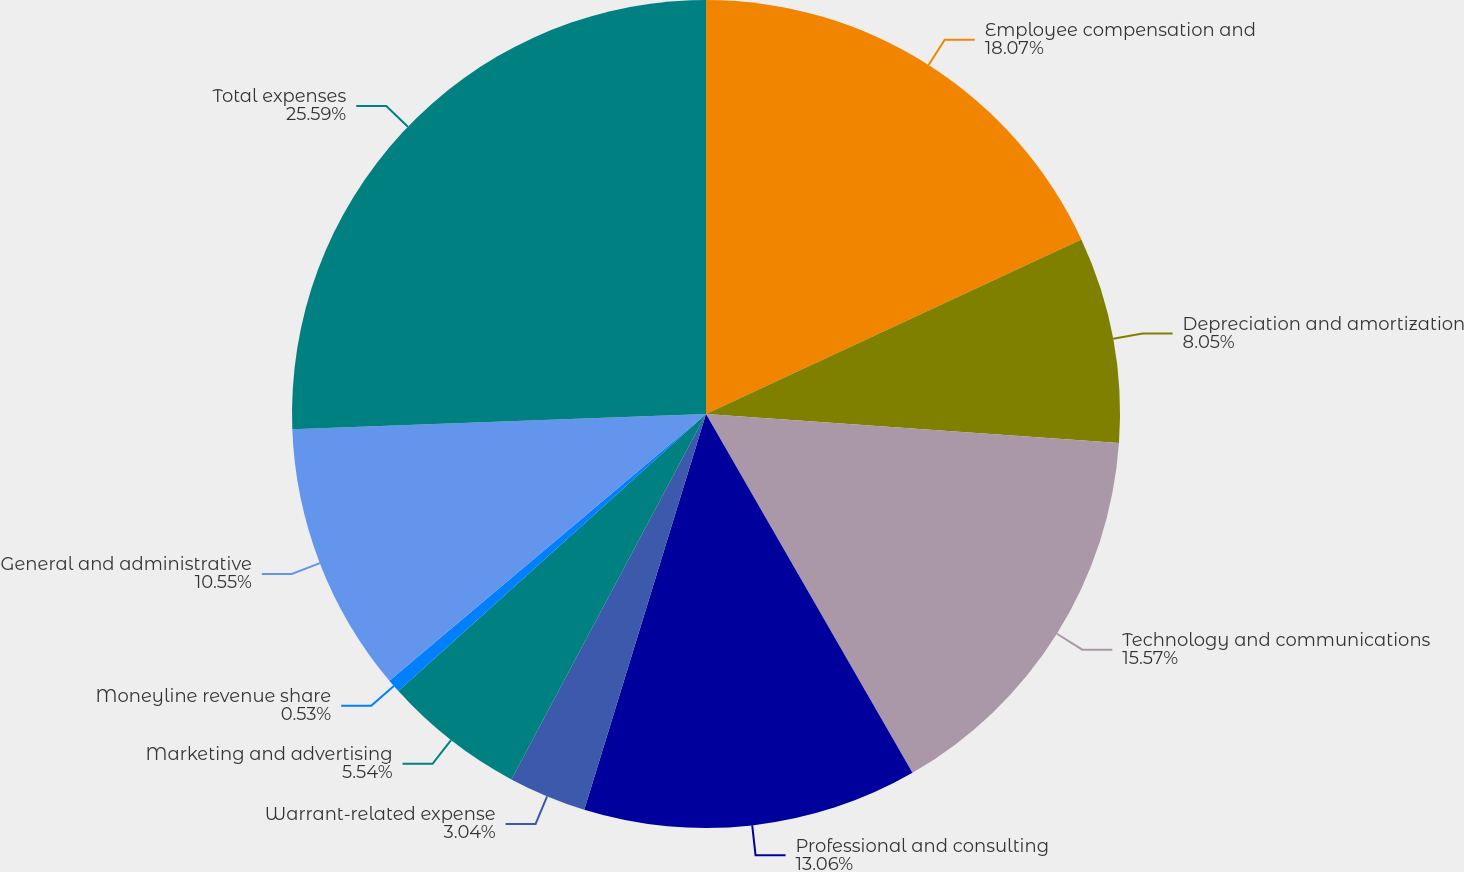Convert chart to OTSL. <chart><loc_0><loc_0><loc_500><loc_500><pie_chart><fcel>Employee compensation and<fcel>Depreciation and amortization<fcel>Technology and communications<fcel>Professional and consulting<fcel>Warrant-related expense<fcel>Marketing and advertising<fcel>Moneyline revenue share<fcel>General and administrative<fcel>Total expenses<nl><fcel>18.07%<fcel>8.05%<fcel>15.57%<fcel>13.06%<fcel>3.04%<fcel>5.54%<fcel>0.53%<fcel>10.55%<fcel>25.59%<nl></chart> 